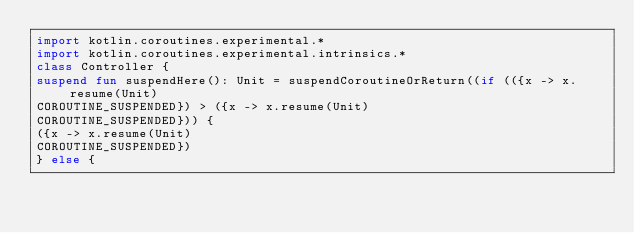<code> <loc_0><loc_0><loc_500><loc_500><_Kotlin_>import kotlin.coroutines.experimental.*
import kotlin.coroutines.experimental.intrinsics.*
class Controller {
suspend fun suspendHere(): Unit = suspendCoroutineOrReturn((if (({x -> x.resume(Unit)
COROUTINE_SUSPENDED}) > ({x -> x.resume(Unit)
COROUTINE_SUSPENDED})) {
({x -> x.resume(Unit)
COROUTINE_SUSPENDED})
} else {</code> 